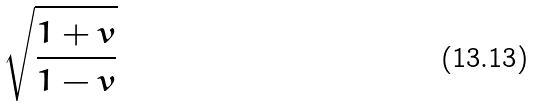Convert formula to latex. <formula><loc_0><loc_0><loc_500><loc_500>\sqrt { \frac { 1 + v } { 1 - v } }</formula> 